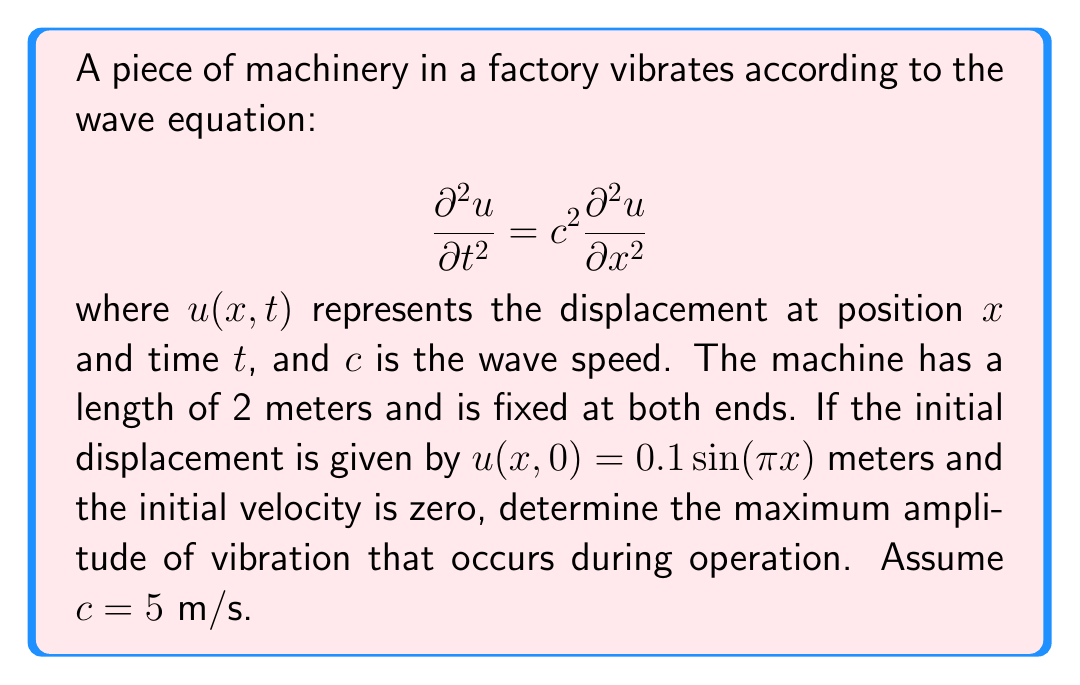Provide a solution to this math problem. To solve this problem, we'll follow these steps:

1) The general solution for the wave equation with fixed ends is:

   $$u(x,t) = \sum_{n=1}^{\infty} (A_n \cos(\omega_n t) + B_n \sin(\omega_n t)) \sin(\frac{n\pi x}{L})$$

   where $L$ is the length of the machine (2 meters), and $\omega_n = \frac{n\pi c}{L}$.

2) Given the initial conditions, we can see that only the first mode ($n=1$) is excited, and $B_1 = 0$ (since initial velocity is zero). So our solution simplifies to:

   $$u(x,t) = A_1 \cos(\omega_1 t) \sin(\frac{\pi x}{2})$$

3) From the initial displacement, we can determine that $A_1 = 0.1$ meters.

4) The angular frequency $\omega_1$ is:

   $$\omega_1 = \frac{\pi c}{L} = \frac{\pi \cdot 5}{2} = \frac{5\pi}{2} \text{ rad/s}$$

5) Therefore, our complete solution is:

   $$u(x,t) = 0.1 \cos(\frac{5\pi}{2} t) \sin(\frac{\pi x}{2})$$

6) The maximum amplitude will occur when $\cos(\frac{5\pi}{2} t) = \pm 1$ and $\sin(\frac{\pi x}{2}) = \pm 1$.

7) Thus, the maximum amplitude is 0.1 meters.
Answer: 0.1 meters 